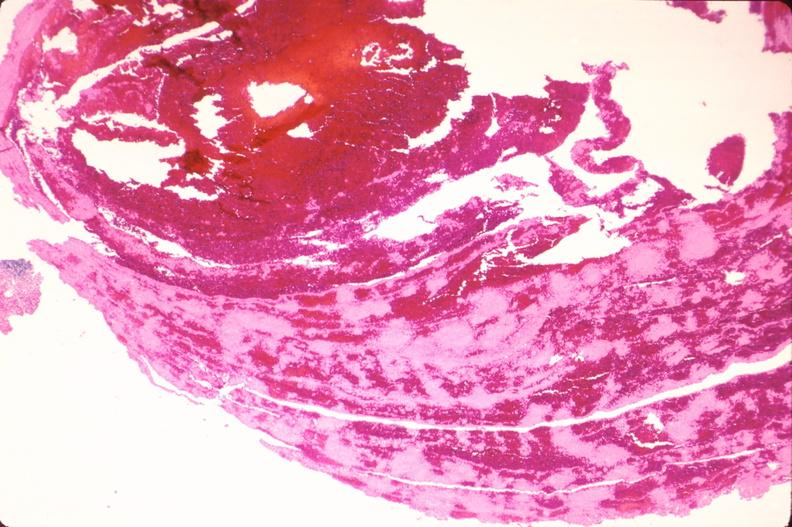what is present?
Answer the question using a single word or phrase. Vasculature 